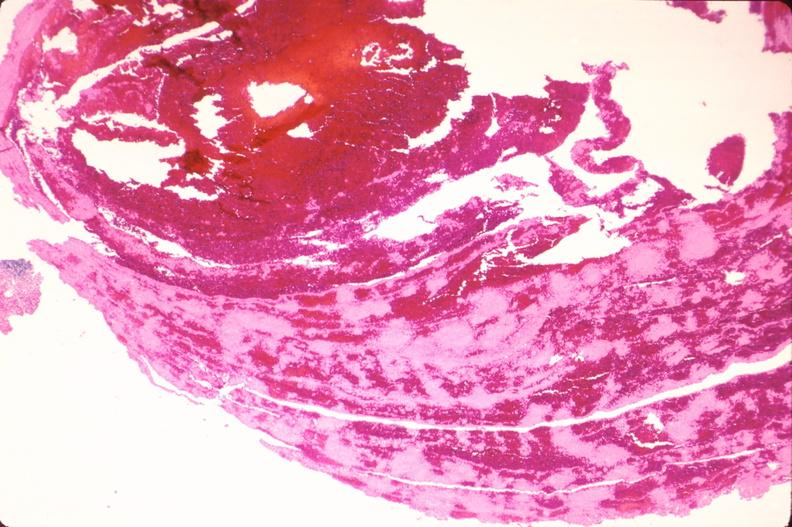what is present?
Answer the question using a single word or phrase. Vasculature 